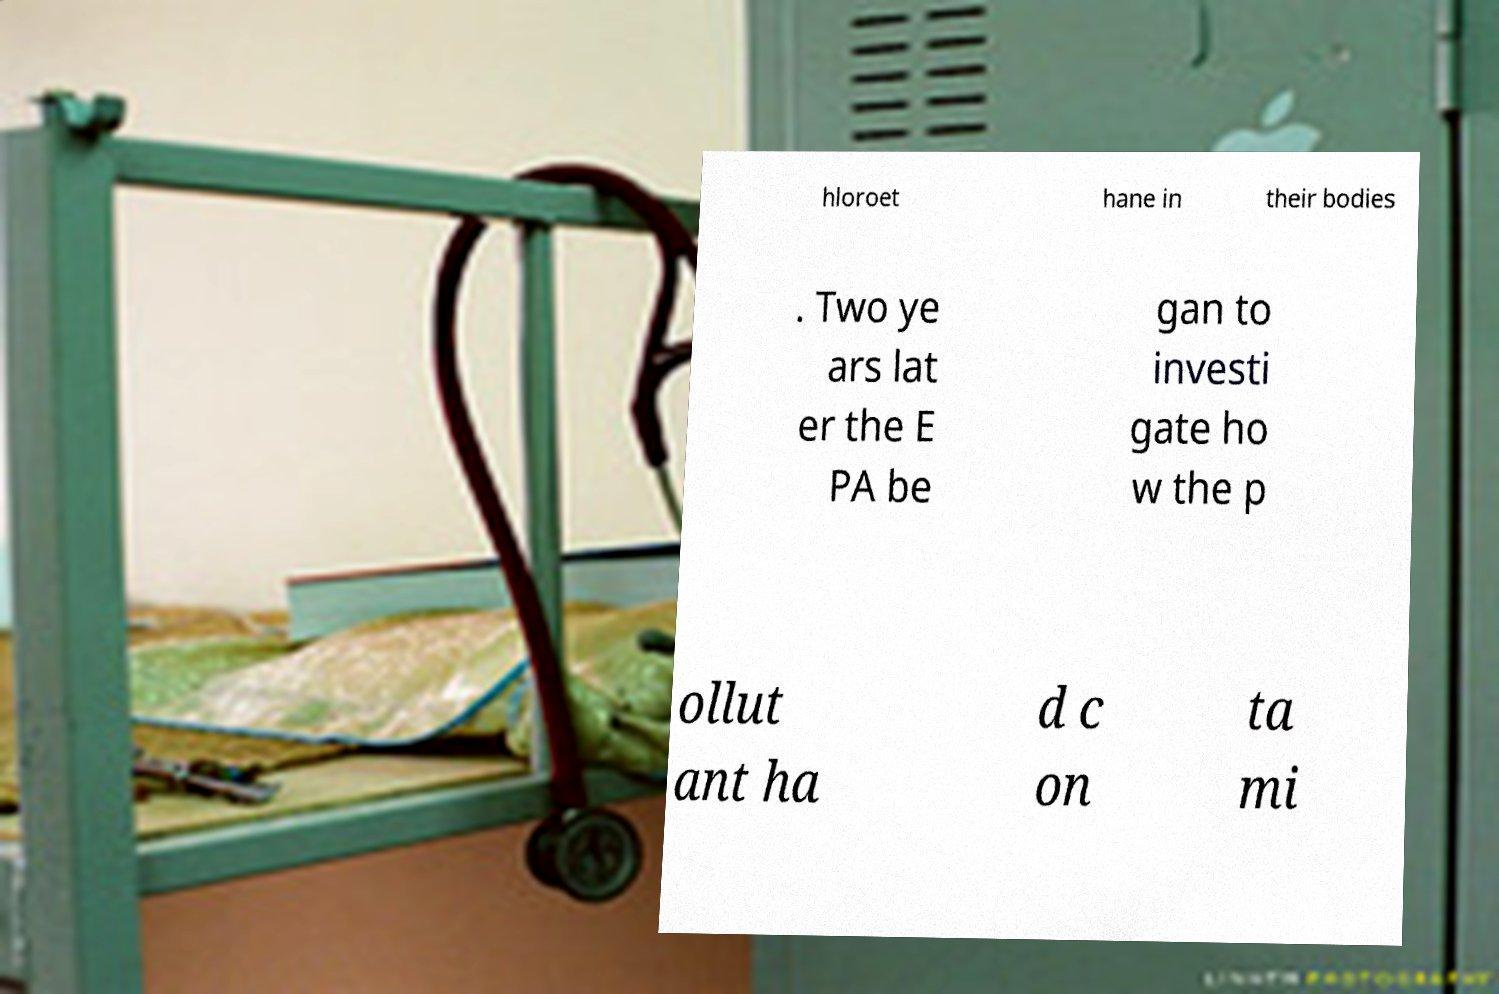Can you read and provide the text displayed in the image?This photo seems to have some interesting text. Can you extract and type it out for me? hloroet hane in their bodies . Two ye ars lat er the E PA be gan to investi gate ho w the p ollut ant ha d c on ta mi 